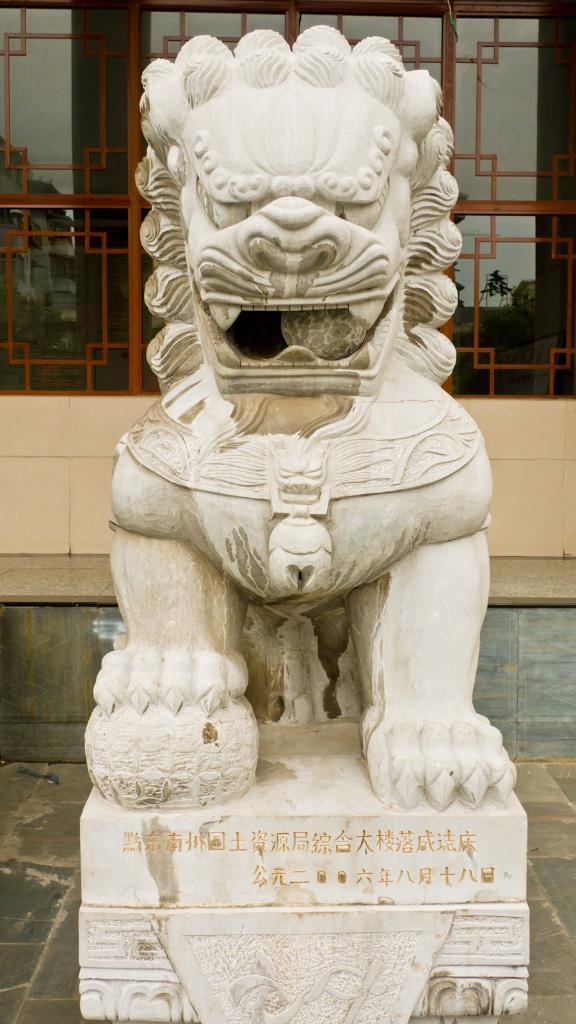Can you describe this image briefly? There is a statue at the bottom of this image. We can see a glass wall in the background. 